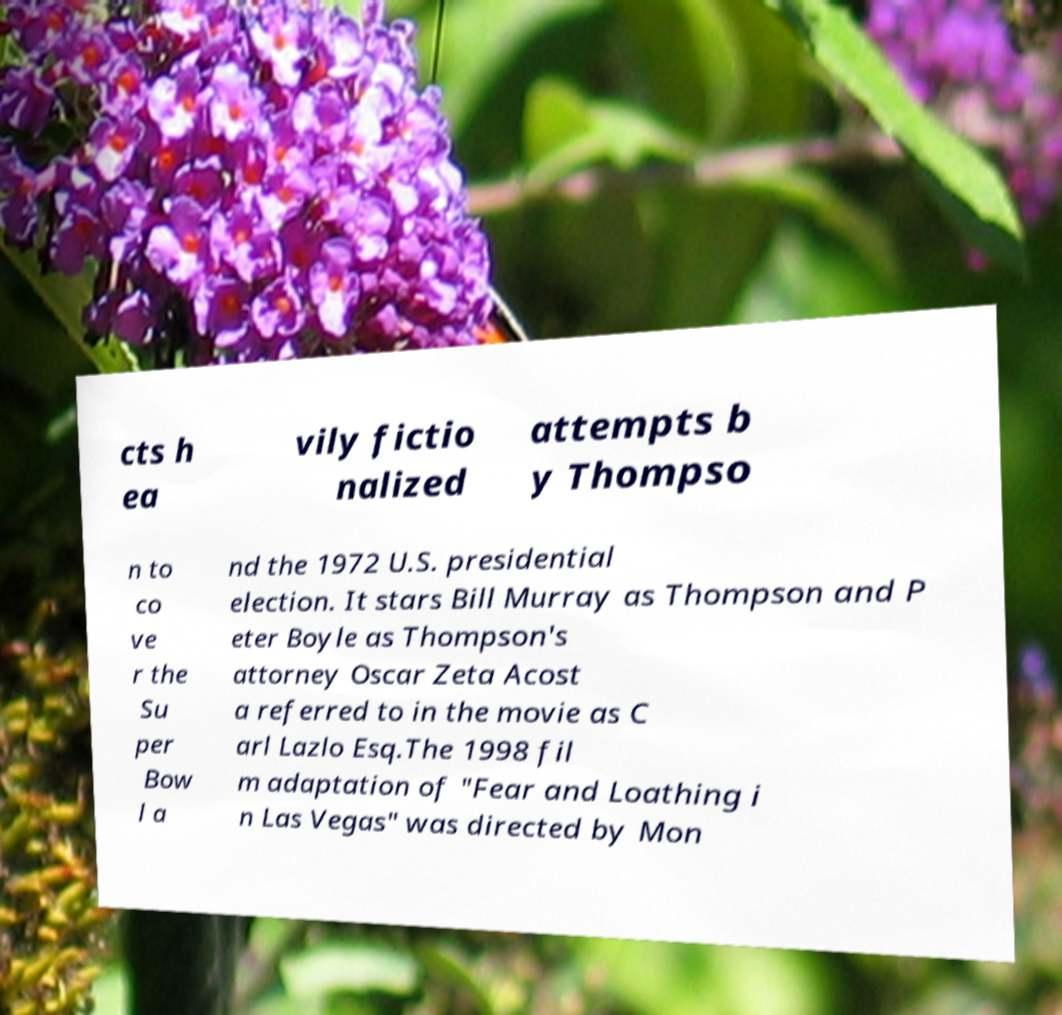Could you extract and type out the text from this image? cts h ea vily fictio nalized attempts b y Thompso n to co ve r the Su per Bow l a nd the 1972 U.S. presidential election. It stars Bill Murray as Thompson and P eter Boyle as Thompson's attorney Oscar Zeta Acost a referred to in the movie as C arl Lazlo Esq.The 1998 fil m adaptation of "Fear and Loathing i n Las Vegas" was directed by Mon 